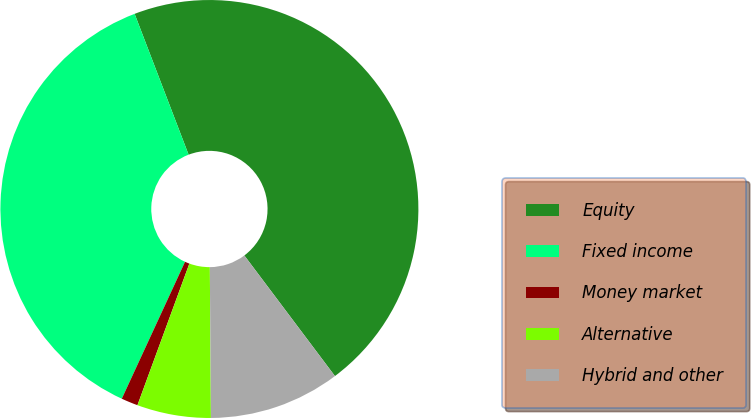Convert chart. <chart><loc_0><loc_0><loc_500><loc_500><pie_chart><fcel>Equity<fcel>Fixed income<fcel>Money market<fcel>Alternative<fcel>Hybrid and other<nl><fcel>45.57%<fcel>37.29%<fcel>1.29%<fcel>5.71%<fcel>10.14%<nl></chart> 